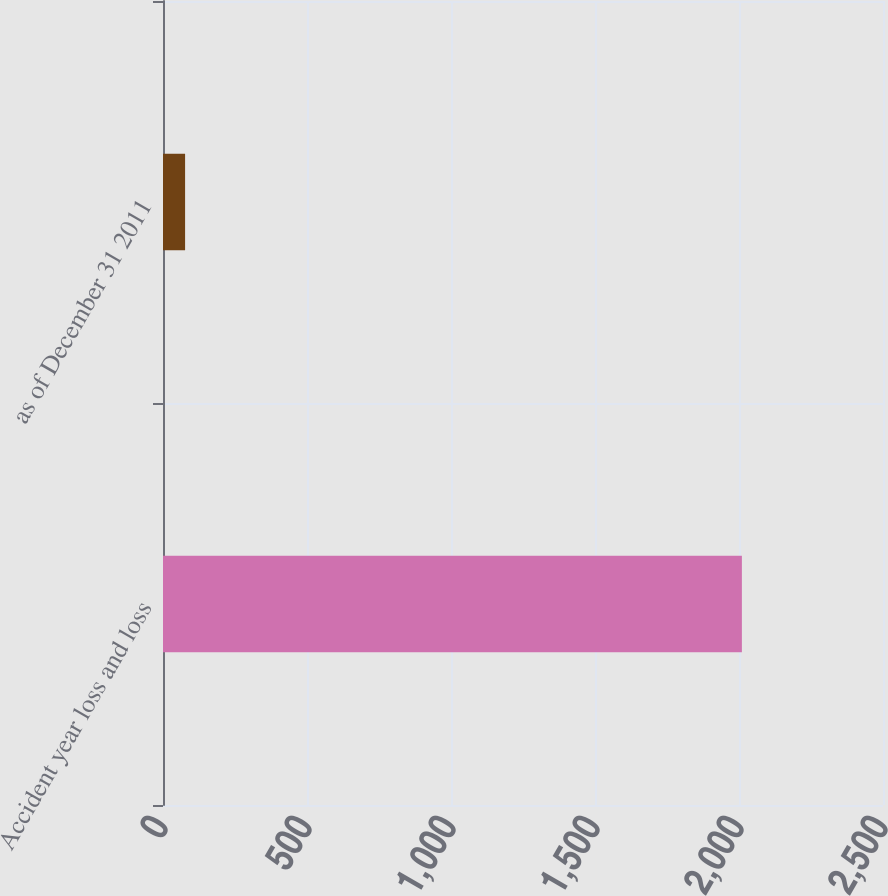Convert chart. <chart><loc_0><loc_0><loc_500><loc_500><bar_chart><fcel>Accident year loss and loss<fcel>as of December 31 2011<nl><fcel>2010<fcel>76.7<nl></chart> 